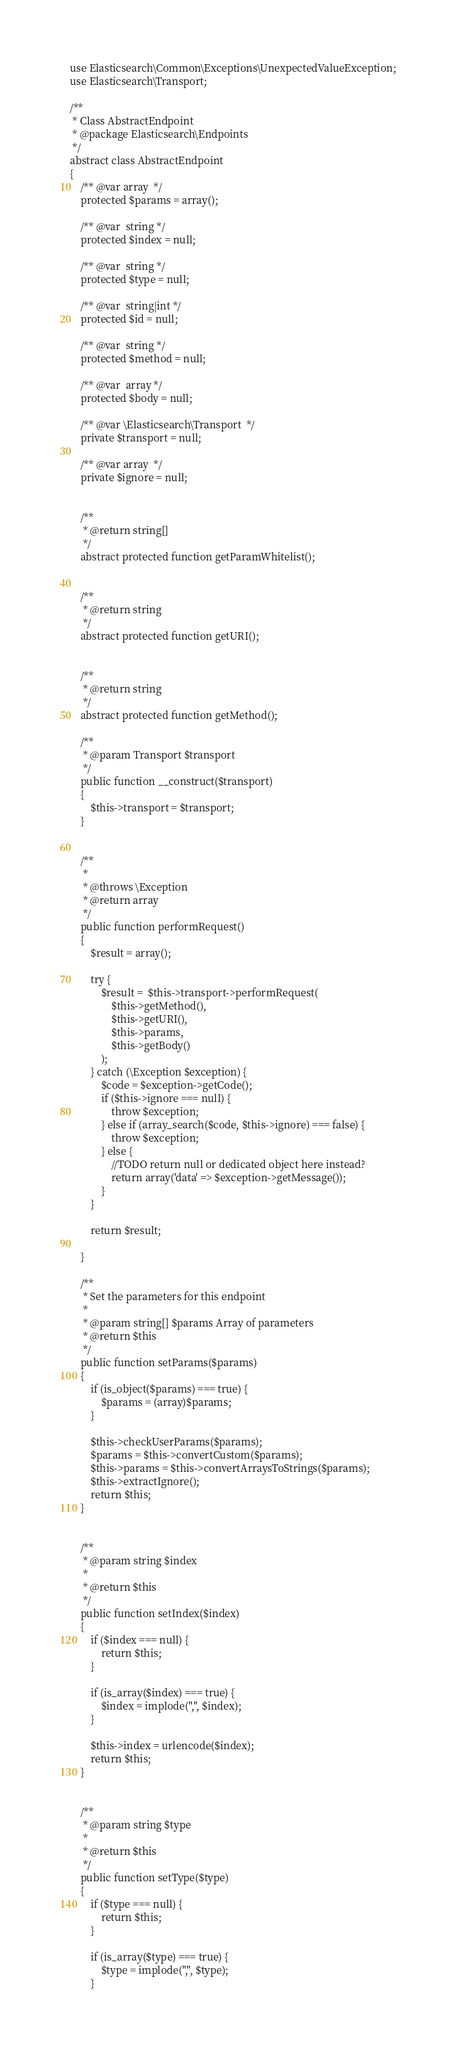<code> <loc_0><loc_0><loc_500><loc_500><_PHP_>

use Elasticsearch\Common\Exceptions\UnexpectedValueException;
use Elasticsearch\Transport;

/**
 * Class AbstractEndpoint
 * @package Elasticsearch\Endpoints
 */
abstract class AbstractEndpoint
{
    /** @var array  */
    protected $params = array();

    /** @var  string */
    protected $index = null;

    /** @var  string */
    protected $type = null;

    /** @var  string|int */
    protected $id = null;

    /** @var  string */
    protected $method = null;

    /** @var  array */
    protected $body = null;

    /** @var \Elasticsearch\Transport  */
    private $transport = null;

    /** @var array  */
    private $ignore = null;


    /**
     * @return string[]
     */
    abstract protected function getParamWhitelist();


    /**
     * @return string
     */
    abstract protected function getURI();


    /**
     * @return string
     */
    abstract protected function getMethod();

    /**
     * @param Transport $transport
     */
    public function __construct($transport)
    {
        $this->transport = $transport;
    }


    /**
     *
     * @throws \Exception
     * @return array
     */
    public function performRequest()
    {
        $result = array();

        try {
            $result =  $this->transport->performRequest(
                $this->getMethod(),
                $this->getURI(),
                $this->params,
                $this->getBody()
            );
        } catch (\Exception $exception) {
            $code = $exception->getCode();
            if ($this->ignore === null) {
                throw $exception;
            } else if (array_search($code, $this->ignore) === false) {
                throw $exception;
            } else {
                //TODO return null or dedicated object here instead?
                return array('data' => $exception->getMessage());
            }
        }

        return $result;

    }

    /**
     * Set the parameters for this endpoint
     *
     * @param string[] $params Array of parameters
     * @return $this
     */
    public function setParams($params)
    {
        if (is_object($params) === true) {
            $params = (array)$params;
        }

        $this->checkUserParams($params);
        $params = $this->convertCustom($params);
        $this->params = $this->convertArraysToStrings($params);
        $this->extractIgnore();
        return $this;
    }


    /**
     * @param string $index
     *
     * @return $this
     */
    public function setIndex($index)
    {
        if ($index === null) {
            return $this;
        }

        if (is_array($index) === true) {
            $index = implode(",", $index);
        }

        $this->index = urlencode($index);
        return $this;
    }


    /**
     * @param string $type
     *
     * @return $this
     */
    public function setType($type)
    {
        if ($type === null) {
            return $this;
        }

        if (is_array($type) === true) {
            $type = implode(",", $type);
        }
</code> 